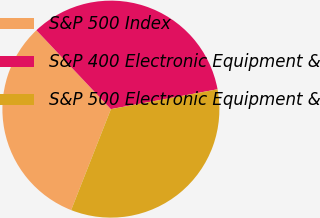Convert chart. <chart><loc_0><loc_0><loc_500><loc_500><pie_chart><fcel>S&P 500 Index<fcel>S&P 400 Electronic Equipment &<fcel>S&P 500 Electronic Equipment &<nl><fcel>31.99%<fcel>34.11%<fcel>33.9%<nl></chart> 